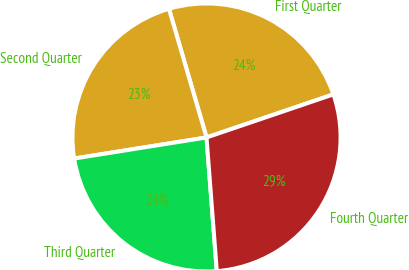<chart> <loc_0><loc_0><loc_500><loc_500><pie_chart><fcel>First Quarter<fcel>Second Quarter<fcel>Third Quarter<fcel>Fourth Quarter<nl><fcel>24.31%<fcel>22.99%<fcel>23.71%<fcel>28.99%<nl></chart> 